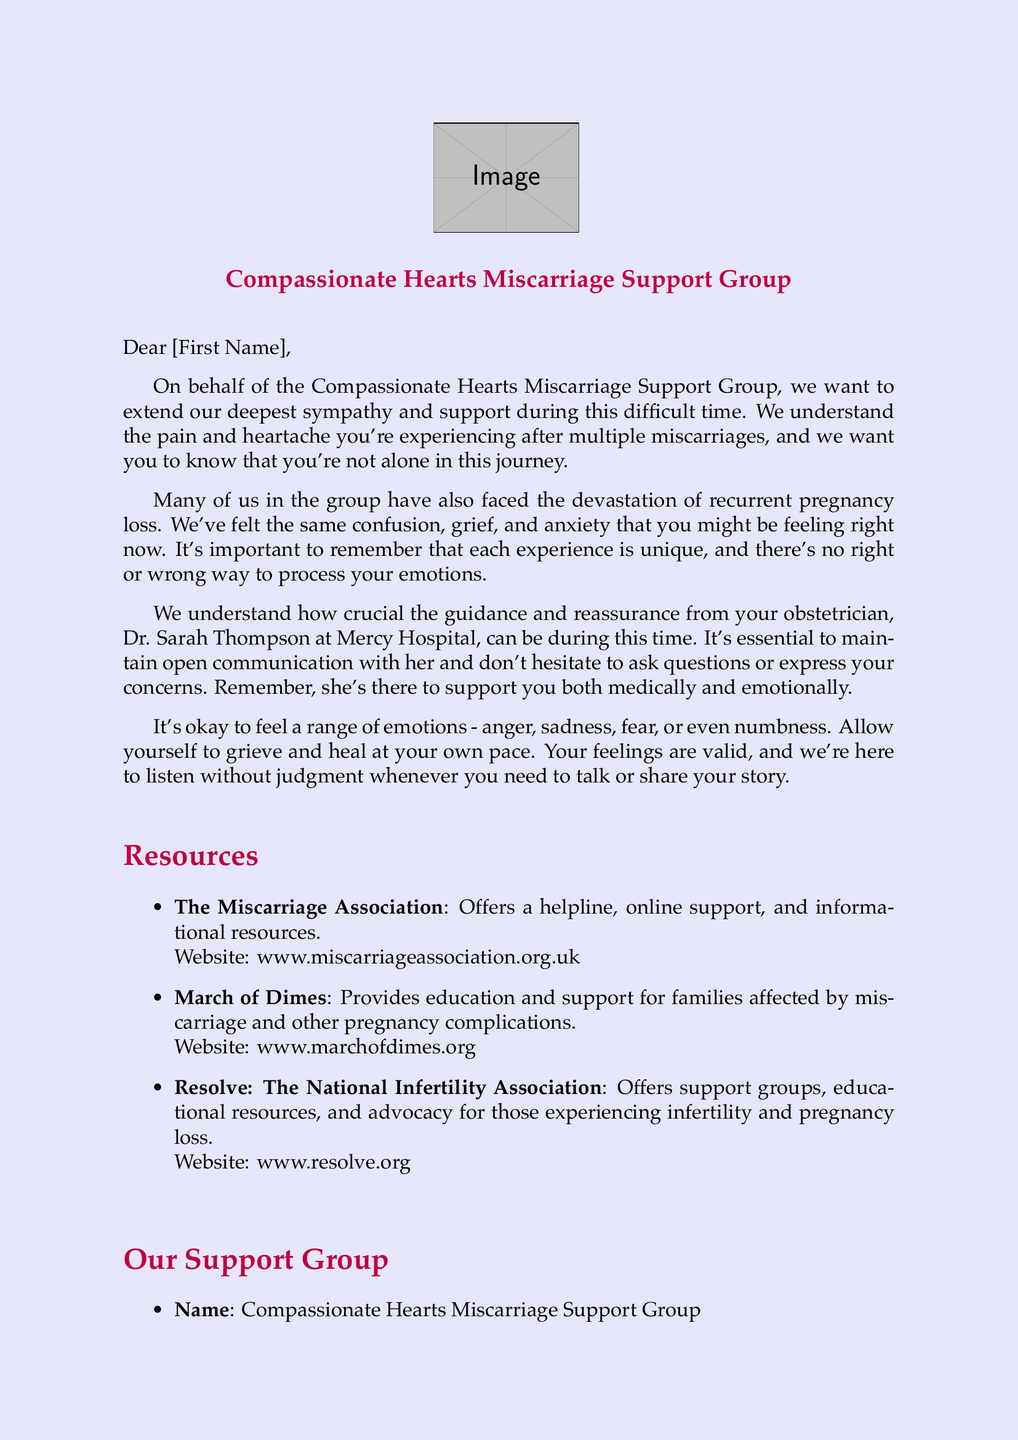What is the name of the support group? The name of the support group is mentioned in the letter's heading as "Compassionate Hearts Miscarriage Support Group."
Answer: Compassionate Hearts Miscarriage Support Group Who is the contact person for the support group? The document lists Emily Johnson as the contact person for the support group.
Answer: Emily Johnson What should you do if you have concerns? The letter advises to maintain open communication with your obstetrician and to express concerns.
Answer: Express concerns How often does the support group meet? The document states that the support group meets every Tuesday.
Answer: Every Tuesday What is the email address for the support group? The document provides the email address as compassionatehearts@email.com.
Answer: compassionatehearts@email.com What are the emotions listed that it's okay to feel? The document mentions anger, sadness, fear, or even numbness as valid emotions to feel.
Answer: Anger, sadness, fear, numbness What website is mentioned for the Miscarriage Association? The letter lists the website for the Miscarriage Association as www.miscarriageassociation.org.uk.
Answer: www.miscarriageassociation.org.uk Where does the support group meet? The letter specifies the meeting location as the Community Center on 123 Main Street.
Answer: Community Center on 123 Main Street What is emphasized about each experience of miscarriage? The document emphasizes that "each experience is unique."
Answer: Each experience is unique 